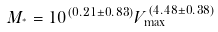Convert formula to latex. <formula><loc_0><loc_0><loc_500><loc_500>M _ { ^ { * } } = 1 0 ^ { ( 0 . 2 1 \pm 0 . 8 3 ) } V _ { \max } ^ { ( 4 . 4 8 \pm 0 . 3 8 ) }</formula> 